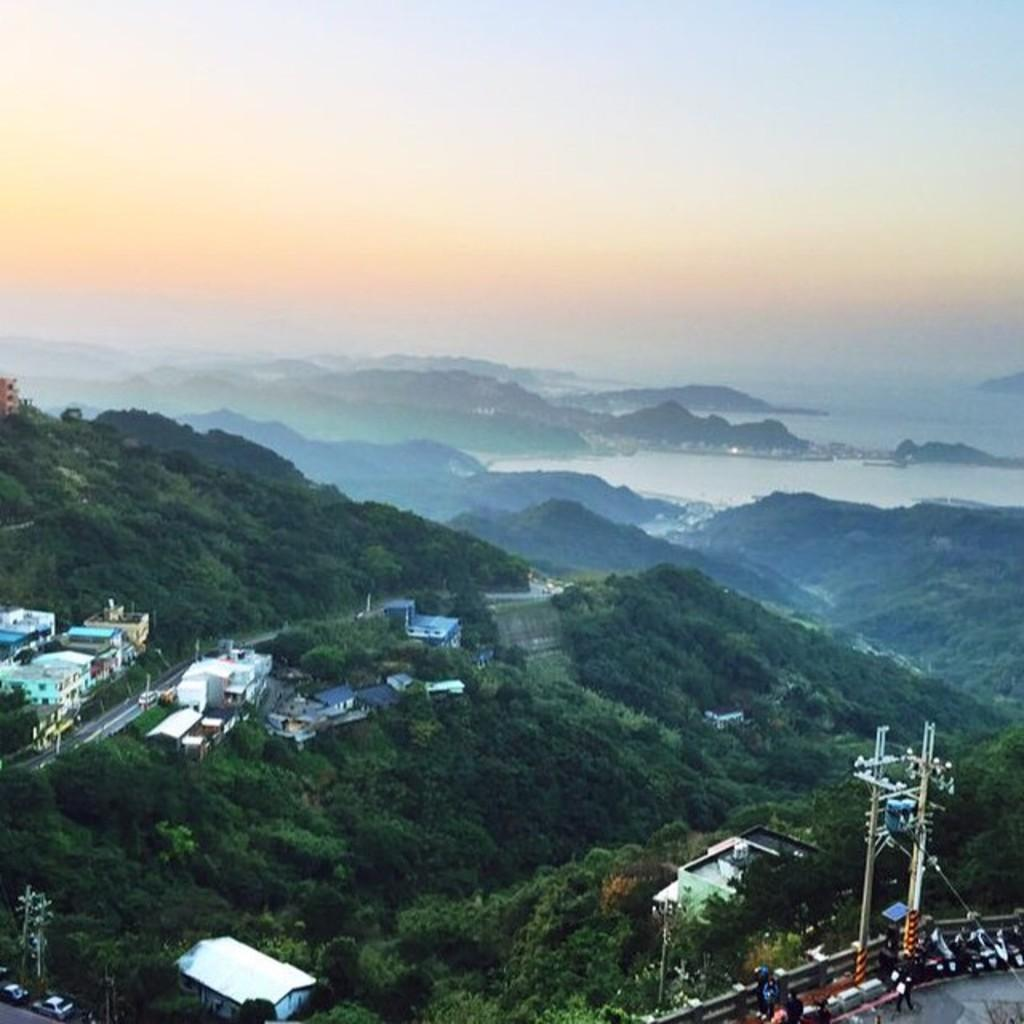What type of structures can be seen in the image? There are buildings in the image. What is happening on the road in the image? Vehicles are present on the road in the image. What type of natural elements can be seen in the image? Trees are visible in the image. What type of barrier is present in the image? There is a wall in the image. What else can be seen in the image besides the buildings, vehicles, trees, and wall? There are objects in the image. What is visible in the background of the image? Mountains and the sky are present in the background of the image. What type of bell can be heard ringing in the image? There is no bell present in the image, and therefore no sound can be heard. How many friends are visible in the image? There is no mention of friends in the image, as the focus is on buildings, vehicles, trees, wall, objects, mountains, and the sky. 